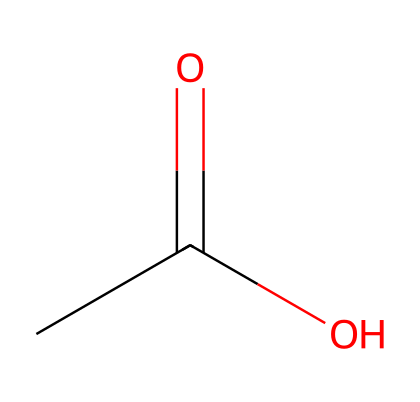What is the common name of this compound? The SMILES representation CC(=O)O indicates a simple structure with one carbonyl group (C=O) and a hydroxyl group (O), which is characteristic of acetic acid.
Answer: acetic acid How many carbons are in this molecule? The SMILES structure shows a chain with two carbon atoms; one from the methyl group (CH3) and one from the carbonyl group.
Answer: two What type of functional group is present in this molecule? The presence of the carboxylic acid functional group (COOH) is evident from the hydroxyl (OH) attached to the carbonyl carbon.
Answer: carboxylic acid What is the pH range of acetic acid in solution? Acetic acid is a weak acid and typically has a pH range of around 2.4 to 3.4 when in dilute solutions, which can be identified based on its dissociation in water.
Answer: 2.4 to 3.4 Why is acetic acid used for maintaining pH levels? The weak acid ionizes partially in water, allowing it to donate protons and thus help stabilize pH levels in a solution, particularly in biological and chemical applications.
Answer: stabilizes pH What is the number of hydrogen atoms in acetic acid? The structure CC(=O)O shows one hydrogen from the methyl group and one from the hydroxyl group, totaling four hydrogen atoms in acetic acid.
Answer: four What role does acetic acid play in buffer solutions? Acetic acid acts as a weak acid in buffer solutions that can resist changes in pH by either donating or accepting protons as needed when strong acids or bases are added.
Answer: weak acid 